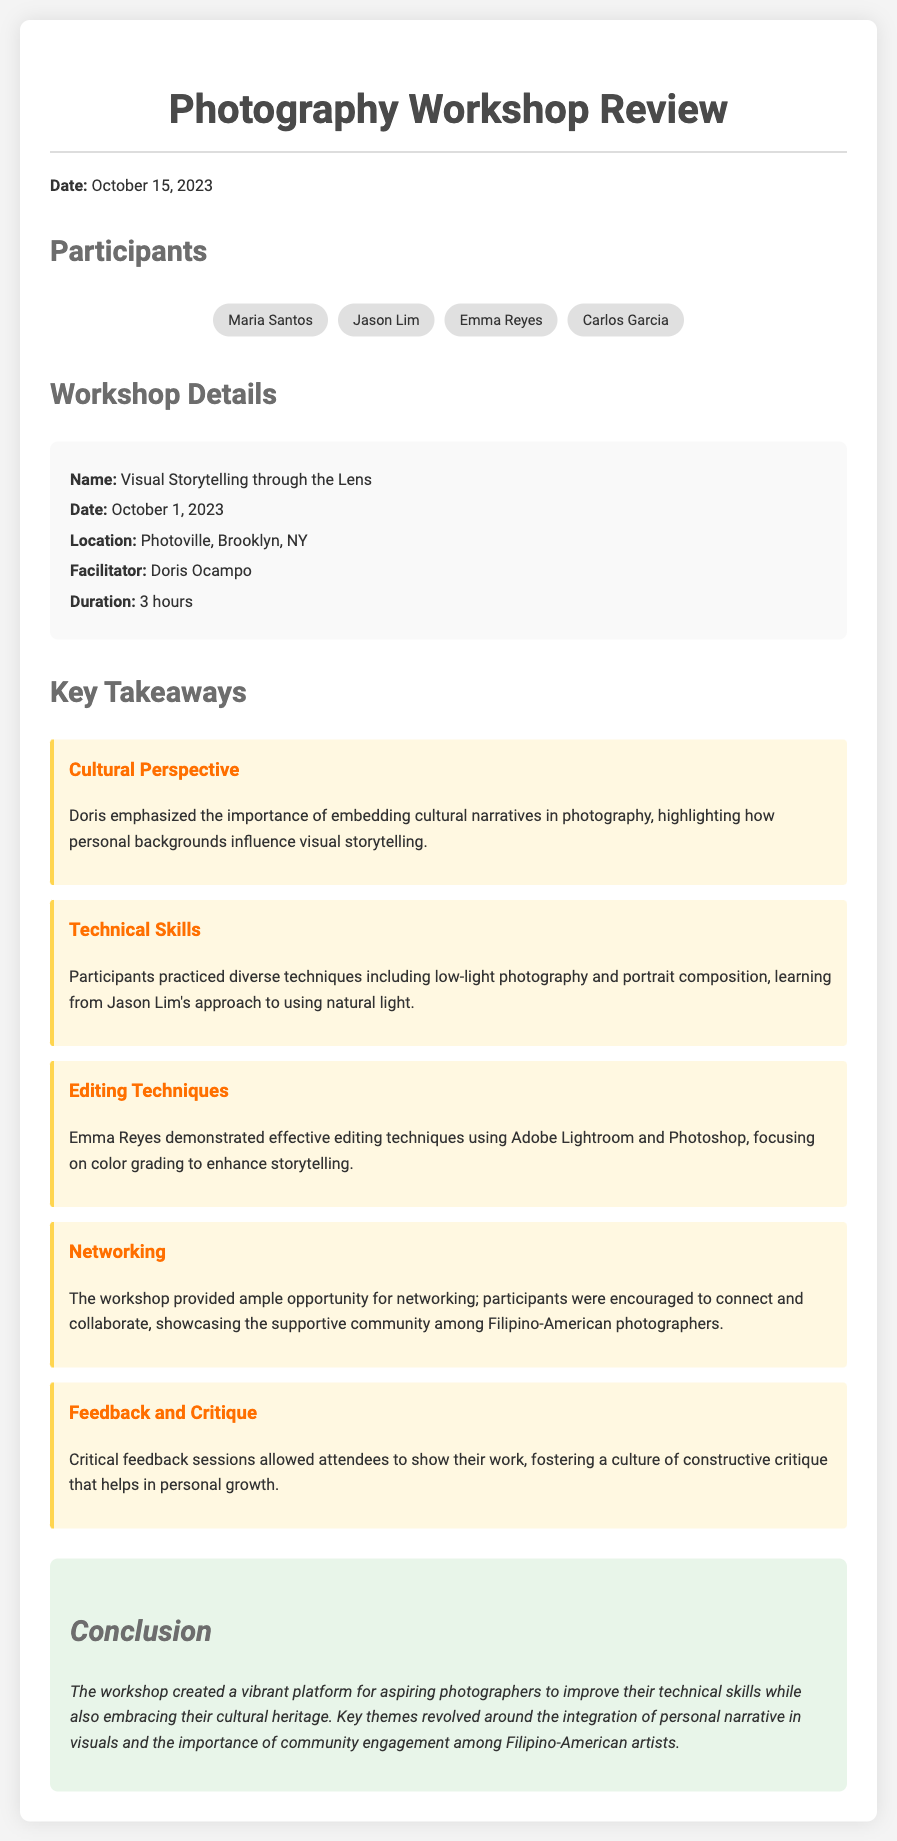what was the date of the workshop? The date of the workshop is specifically mentioned in the document as October 1, 2023.
Answer: October 1, 2023 who facilitated the workshop? The facilitator of the workshop is listed in the workshop details section of the document as Doris Ocampo.
Answer: Doris Ocampo how long was the workshop? The duration of the workshop is stated as 3 hours.
Answer: 3 hours which location hosted the workshop? The location of the workshop is mentioned as Photoville, Brooklyn, NY.
Answer: Photoville, Brooklyn, NY what was one of the key takeaways about cultural narratives? The takeaway emphasizes that personal backgrounds influence visual storytelling, highlighting the importance of cultural narratives.
Answer: embedding cultural narratives in photography who demonstrated editing techniques during the workshop? The document specifies that Emma Reyes demonstrated effective editing techniques.
Answer: Emma Reyes how many participants are listed? The number of participants mentioned in the document includes four individuals: Maria Santos, Jason Lim, Emma Reyes, and Carlos Garcia.
Answer: four what is one theme discussed in the conclusion regarding personal narrative? The conclusion highlights the integration of personal narrative in visuals as a key theme addressed during the workshop.
Answer: integration of personal narrative in visuals what aspect of community engagement is highlighted? The document talks about the supportive community among Filipino-American photographers in networking opportunities during the workshop.
Answer: supportive community among Filipino-American photographers 